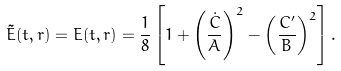<formula> <loc_0><loc_0><loc_500><loc_500>\tilde { E } ( t , r ) = E ( t , r ) = \frac { 1 } { 8 } \left [ 1 + \left ( \frac { \dot { C } } { A } \right ) ^ { 2 } - \left ( \frac { C ^ { \prime } } { B } \right ) ^ { 2 } \right ] .</formula> 